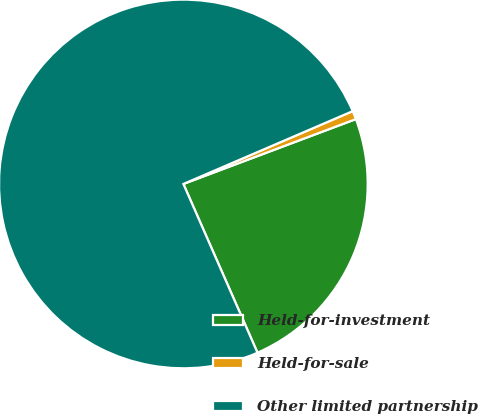Convert chart. <chart><loc_0><loc_0><loc_500><loc_500><pie_chart><fcel>Held-for-investment<fcel>Held-for-sale<fcel>Other limited partnership<nl><fcel>24.14%<fcel>0.74%<fcel>75.12%<nl></chart> 